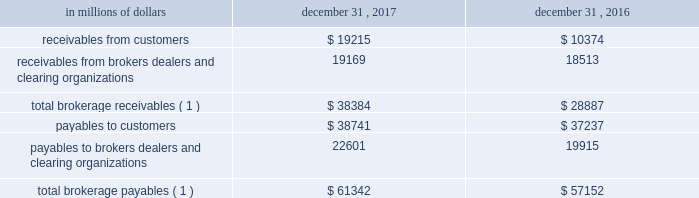12 .
Brokerage receivables and brokerage payables citi has receivables and payables for financial instruments sold to and purchased from brokers , dealers and customers , which arise in the ordinary course of business .
Citi is exposed to risk of loss from the inability of brokers , dealers or customers to pay for purchases or to deliver the financial instruments sold , in which case citi would have to sell or purchase the financial instruments at prevailing market prices .
Credit risk is reduced to the extent that an exchange or clearing organization acts as a counterparty to the transaction and replaces the broker , dealer or customer in question .
Citi seeks to protect itself from the risks associated with customer activities by requiring customers to maintain margin collateral in compliance with regulatory and internal guidelines .
Margin levels are monitored daily , and customers deposit additional collateral as required .
Where customers cannot meet collateral requirements , citi may liquidate sufficient underlying financial instruments to bring the customer into compliance with the required margin level .
Exposure to credit risk is impacted by market volatility , which may impair the ability of clients to satisfy their obligations to citi .
Credit limits are established and closely monitored for customers and for brokers and dealers engaged in forwards , futures and other transactions deemed to be credit sensitive .
Brokerage receivables and brokerage payables consisted of the following: .
Payables to brokers , dealers and clearing organizations 22601 19915 total brokerage payables ( 1 ) $ 61342 $ 57152 ( 1 ) includes brokerage receivables and payables recorded by citi broker- dealer entities that are accounted for in accordance with the aicpa accounting guide for brokers and dealers in securities as codified in asc 940-320. .
As of december 31 2016 what is the ratio of receivables from brokers dealers and clearing organizations to payables to brokers dealers and clearing organizations? 
Computations: (18513 / 19915)
Answer: 0.9296. 